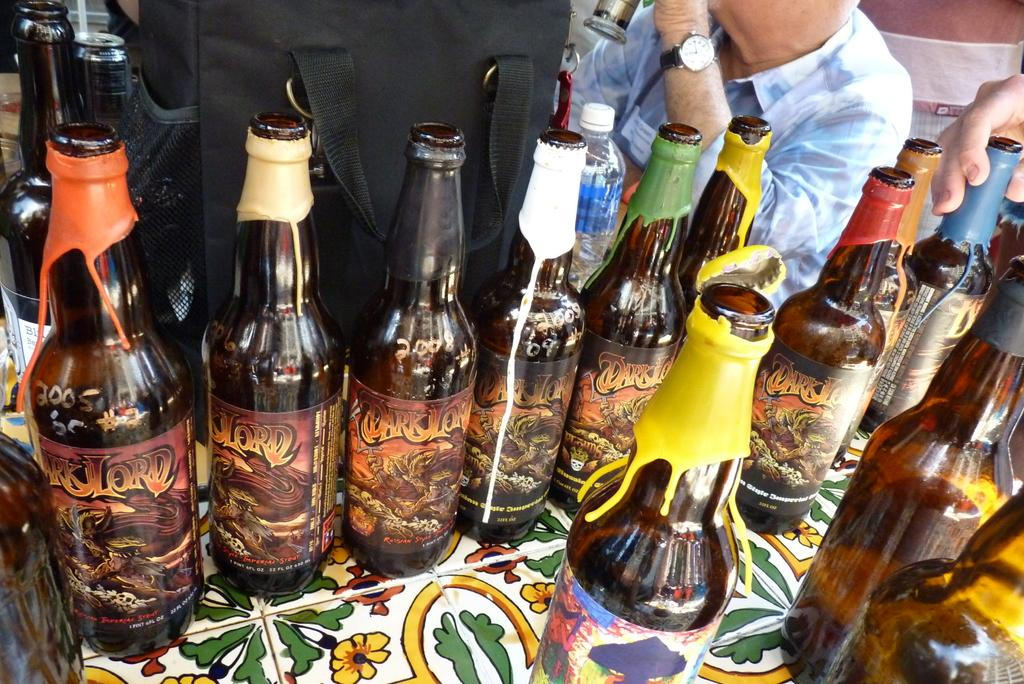<image>
Offer a succinct explanation of the picture presented. bottle of Dark Lord Imperial Stout with colorful wax seals 